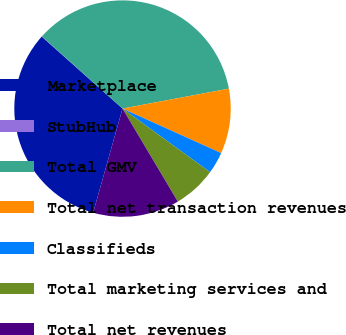Convert chart. <chart><loc_0><loc_0><loc_500><loc_500><pie_chart><fcel>Marketplace<fcel>StubHub<fcel>Total GMV<fcel>Total net transaction revenues<fcel>Classifieds<fcel>Total marketing services and<fcel>Total net revenues<nl><fcel>32.21%<fcel>0.03%<fcel>35.43%<fcel>9.69%<fcel>3.25%<fcel>6.47%<fcel>12.91%<nl></chart> 